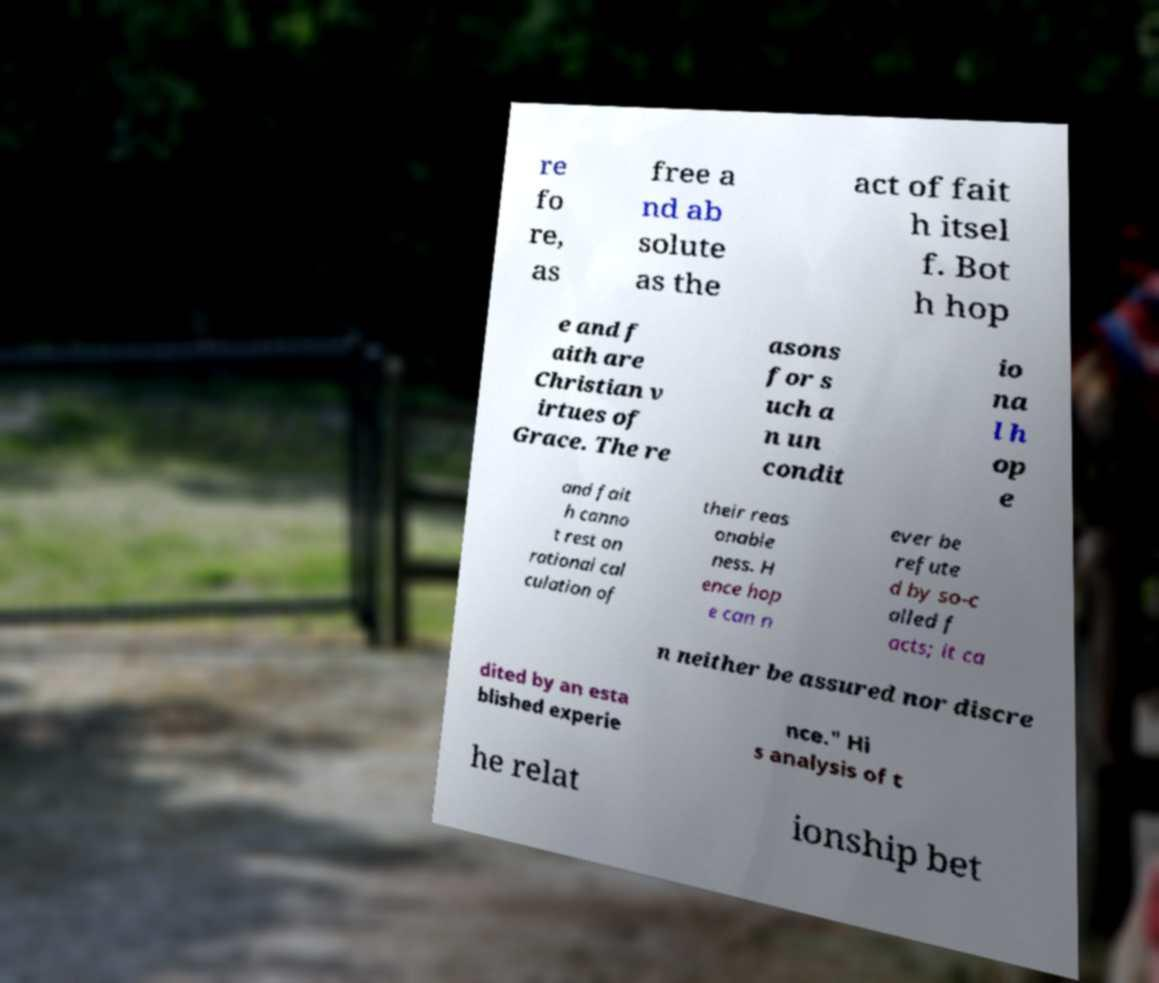Could you assist in decoding the text presented in this image and type it out clearly? re fo re, as free a nd ab solute as the act of fait h itsel f. Bot h hop e and f aith are Christian v irtues of Grace. The re asons for s uch a n un condit io na l h op e and fait h canno t rest on rational cal culation of their reas onable ness. H ence hop e can n ever be refute d by so-c alled f acts; it ca n neither be assured nor discre dited by an esta blished experie nce." Hi s analysis of t he relat ionship bet 